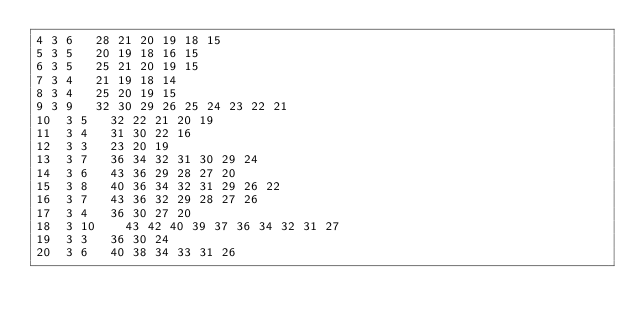<code> <loc_0><loc_0><loc_500><loc_500><_ObjectiveC_>4	3	6		28 21 20 19 18 15 
5	3	5		20 19 18 16 15 
6	3	5		25 21 20 19 15 
7	3	4		21 19 18 14 
8	3	4		25 20 19 15 
9	3	9		32 30 29 26 25 24 23 22 21 
10	3	5		32 22 21 20 19 
11	3	4		31 30 22 16 
12	3	3		23 20 19 
13	3	7		36 34 32 31 30 29 24 
14	3	6		43 36 29 28 27 20 
15	3	8		40 36 34 32 31 29 26 22 
16	3	7		43 36 32 29 28 27 26 
17	3	4		36 30 27 20 
18	3	10		43 42 40 39 37 36 34 32 31 27 
19	3	3		36 30 24 
20	3	6		40 38 34 33 31 26 </code> 